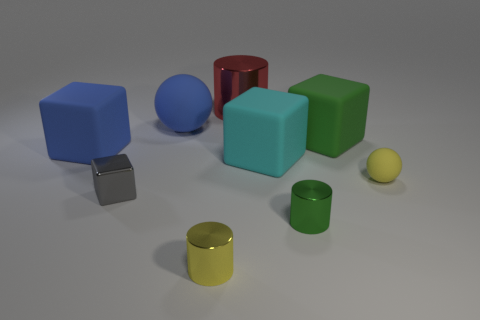What color is the big thing that is the same shape as the tiny green metallic object?
Ensure brevity in your answer.  Red. Do the tiny gray object and the large red object have the same shape?
Your response must be concise. No. What number of small cylinders are the same color as the tiny rubber object?
Provide a succinct answer. 1. Is the number of small yellow matte spheres on the left side of the green shiny thing greater than the number of large green cubes?
Your answer should be compact. No. There is a thing that is the same color as the large sphere; what size is it?
Your answer should be compact. Large. Are there any big green objects of the same shape as the cyan thing?
Offer a terse response. Yes. What number of objects are small rubber balls or red cubes?
Offer a terse response. 1. How many green rubber blocks are on the right side of the metal cylinder behind the tiny yellow object on the right side of the small green cylinder?
Your response must be concise. 1. There is a green thing that is the same shape as the cyan thing; what is its material?
Your response must be concise. Rubber. There is a tiny object that is to the right of the cyan rubber object and to the left of the yellow rubber object; what material is it?
Provide a succinct answer. Metal. 